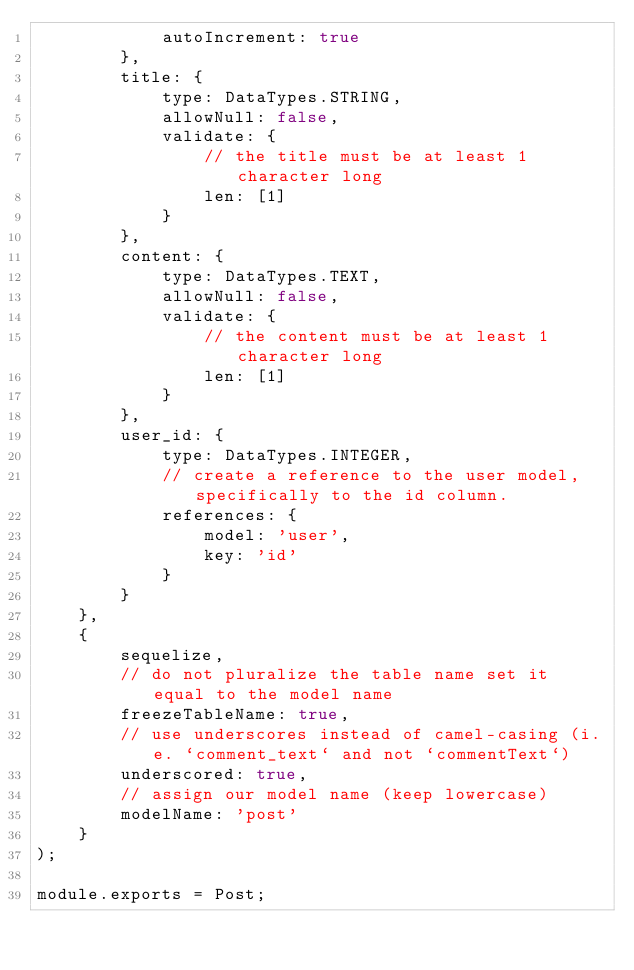<code> <loc_0><loc_0><loc_500><loc_500><_JavaScript_>            autoIncrement: true
        },
        title: {
            type: DataTypes.STRING,
            allowNull: false,
            validate: {
                // the title must be at least 1 character long
                len: [1]
            }
        },
        content: {
            type: DataTypes.TEXT,
            allowNull: false,
            validate: {
                // the content must be at least 1 character long
                len: [1]
            }
        },
        user_id: {
            type: DataTypes.INTEGER,
            // create a reference to the user model, specifically to the id column.
            references: {
                model: 'user',
                key: 'id'
            }
        }
    },
    {
        sequelize,
        // do not pluralize the table name set it equal to the model name
        freezeTableName: true,
        // use underscores instead of camel-casing (i.e. `comment_text` and not `commentText`)
        underscored: true,
        // assign our model name (keep lowercase)
        modelName: 'post'
    }
);

module.exports = Post;</code> 